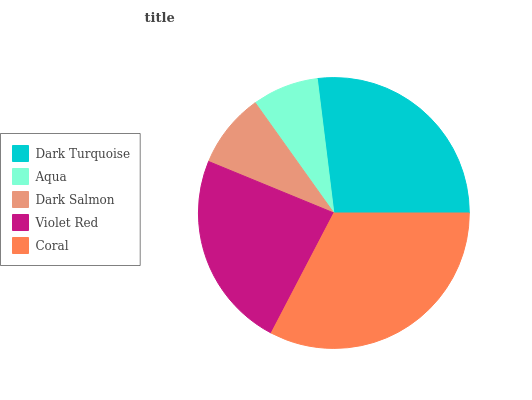Is Aqua the minimum?
Answer yes or no. Yes. Is Coral the maximum?
Answer yes or no. Yes. Is Dark Salmon the minimum?
Answer yes or no. No. Is Dark Salmon the maximum?
Answer yes or no. No. Is Dark Salmon greater than Aqua?
Answer yes or no. Yes. Is Aqua less than Dark Salmon?
Answer yes or no. Yes. Is Aqua greater than Dark Salmon?
Answer yes or no. No. Is Dark Salmon less than Aqua?
Answer yes or no. No. Is Violet Red the high median?
Answer yes or no. Yes. Is Violet Red the low median?
Answer yes or no. Yes. Is Aqua the high median?
Answer yes or no. No. Is Dark Turquoise the low median?
Answer yes or no. No. 